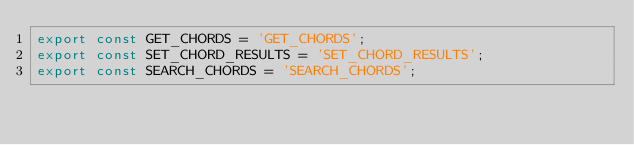Convert code to text. <code><loc_0><loc_0><loc_500><loc_500><_JavaScript_>export const GET_CHORDS = 'GET_CHORDS';
export const SET_CHORD_RESULTS = 'SET_CHORD_RESULTS';
export const SEARCH_CHORDS = 'SEARCH_CHORDS';
</code> 